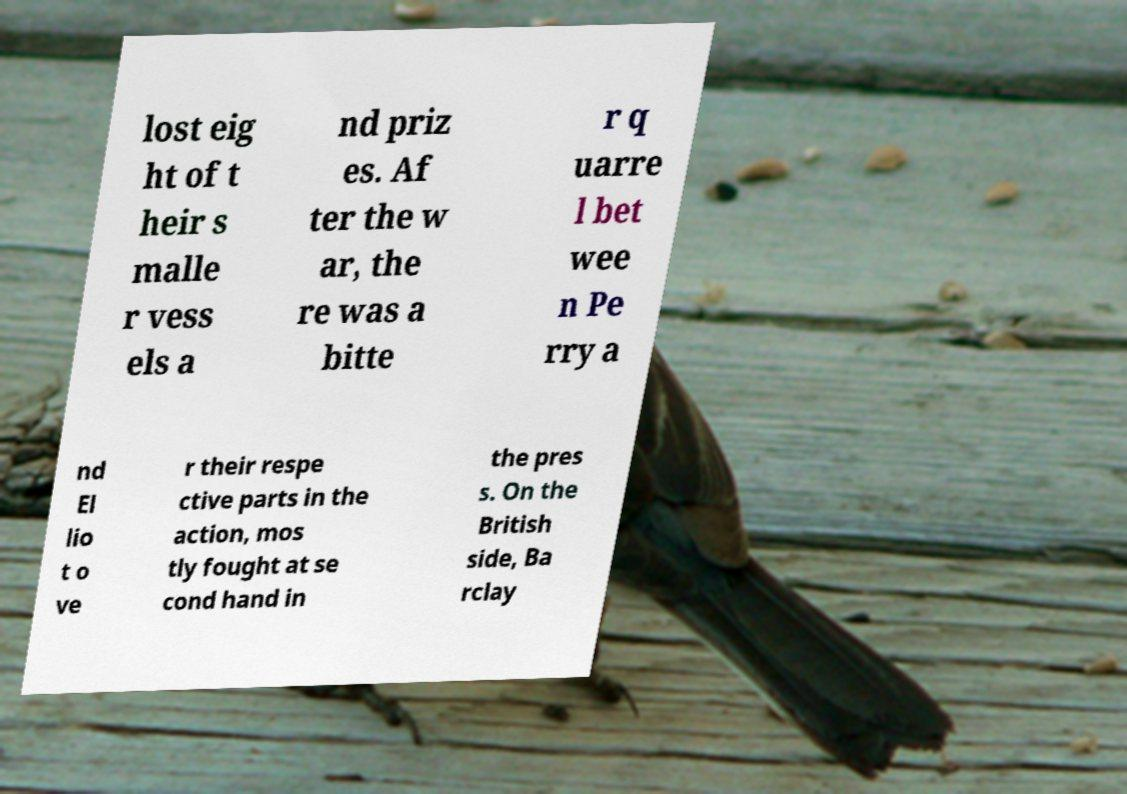Could you assist in decoding the text presented in this image and type it out clearly? lost eig ht of t heir s malle r vess els a nd priz es. Af ter the w ar, the re was a bitte r q uarre l bet wee n Pe rry a nd El lio t o ve r their respe ctive parts in the action, mos tly fought at se cond hand in the pres s. On the British side, Ba rclay 